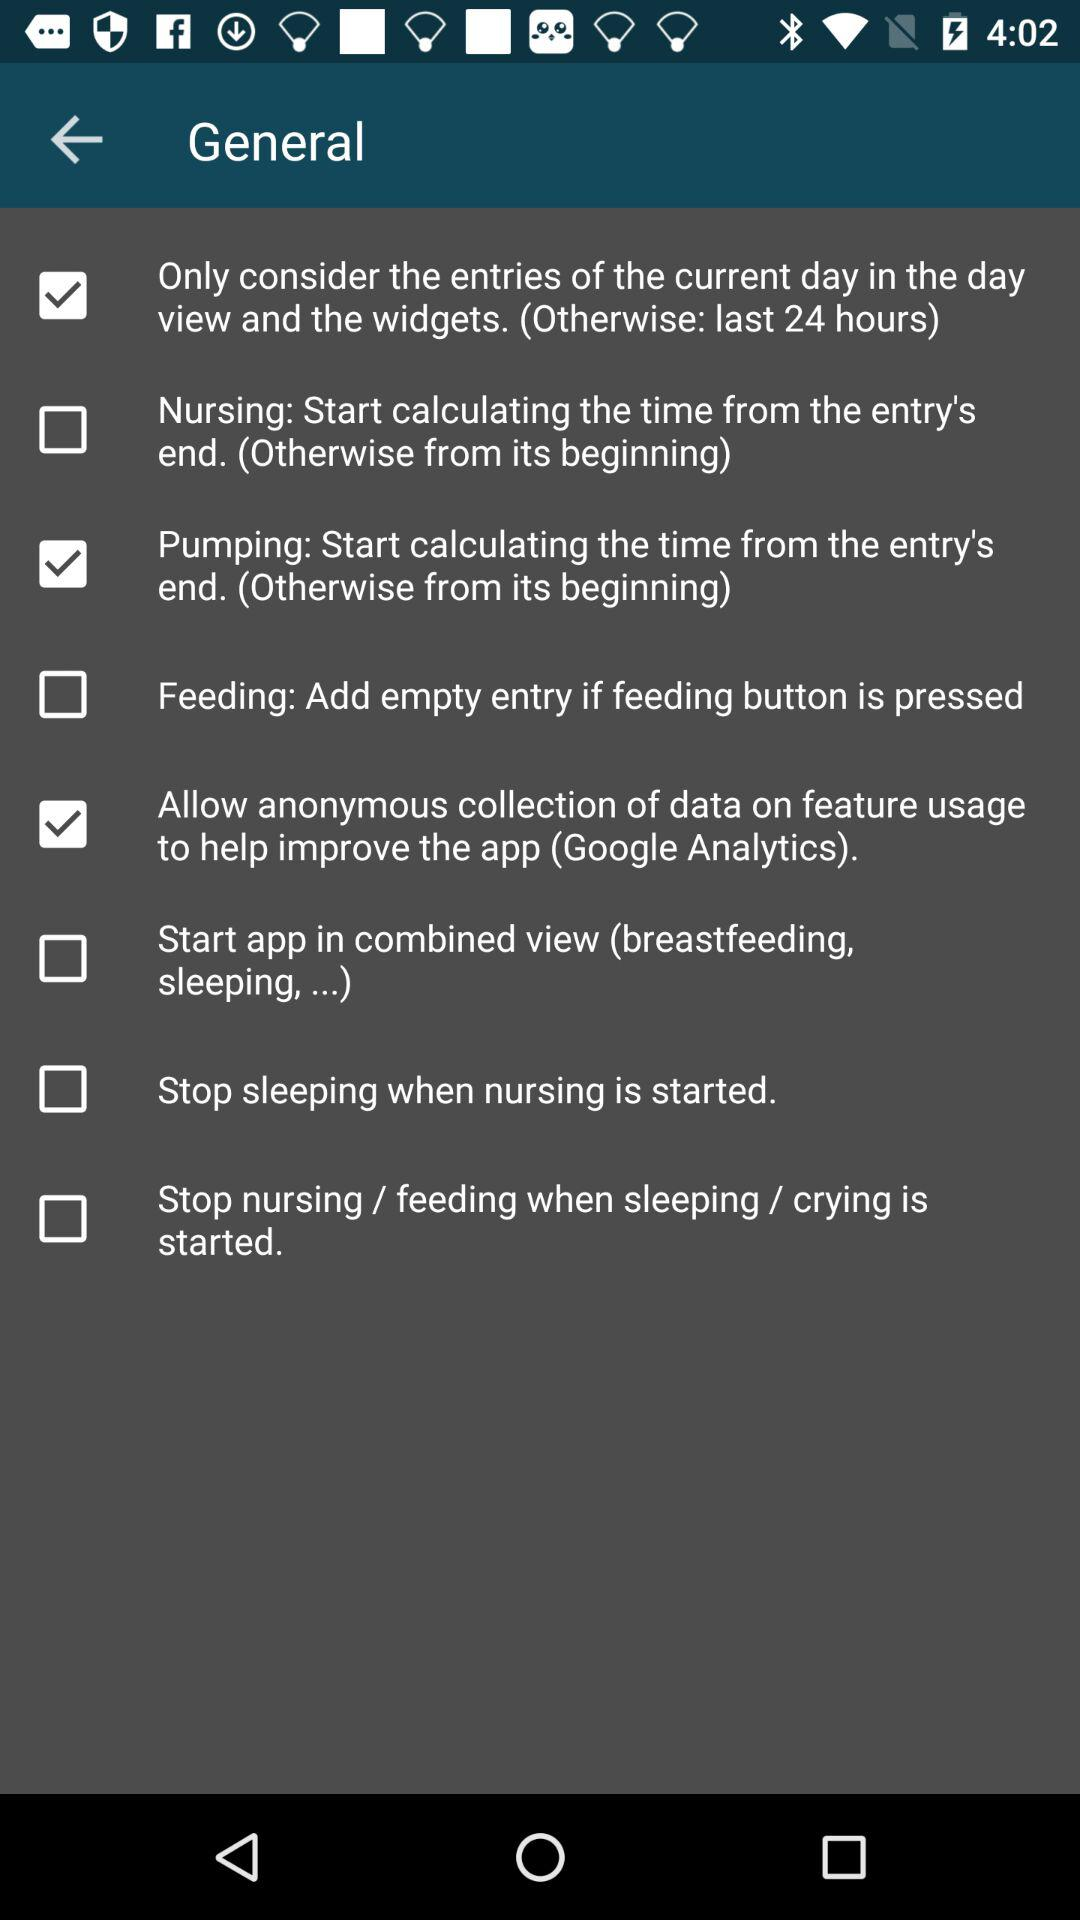What's the status for general setting?
When the provided information is insufficient, respond with <no answer>. <no answer> 